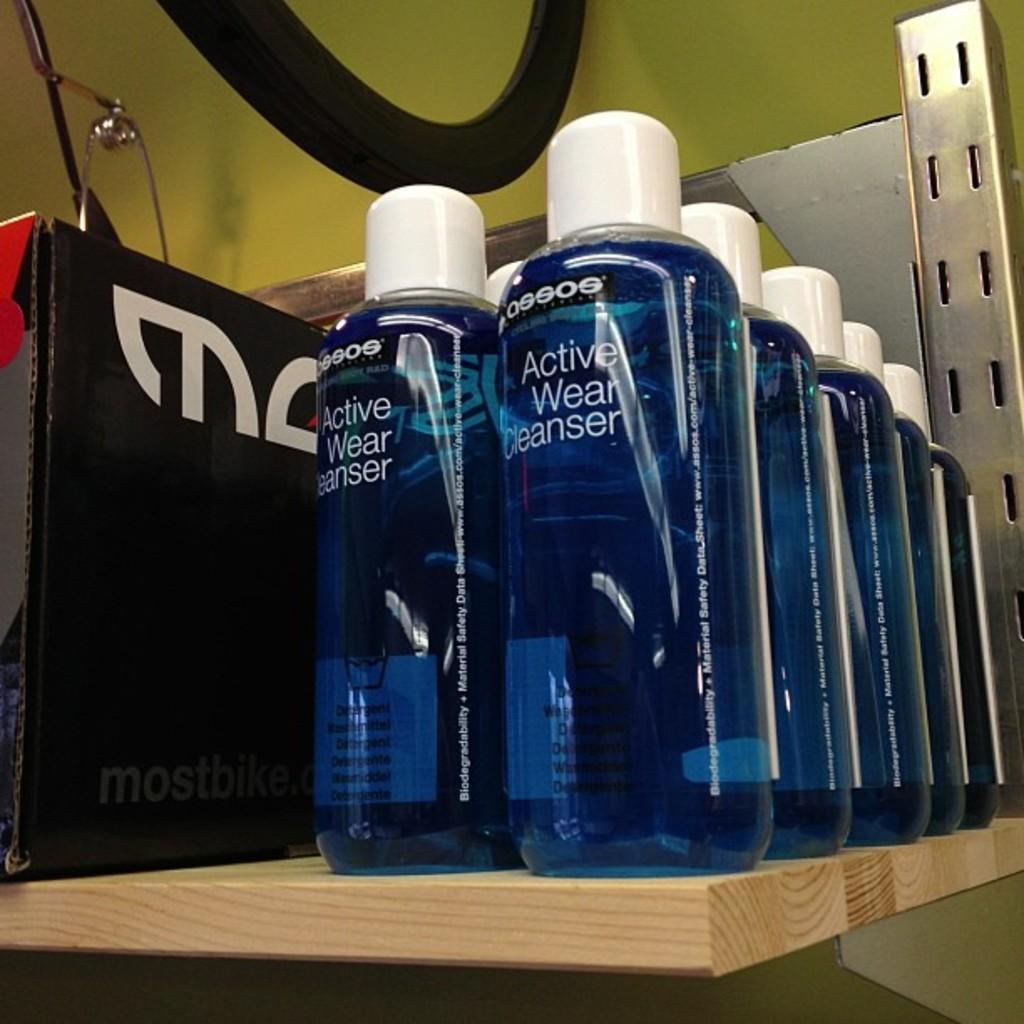<image>
Present a compact description of the photo's key features. rows of blue bottles that say 'active wear cleanser' on them 